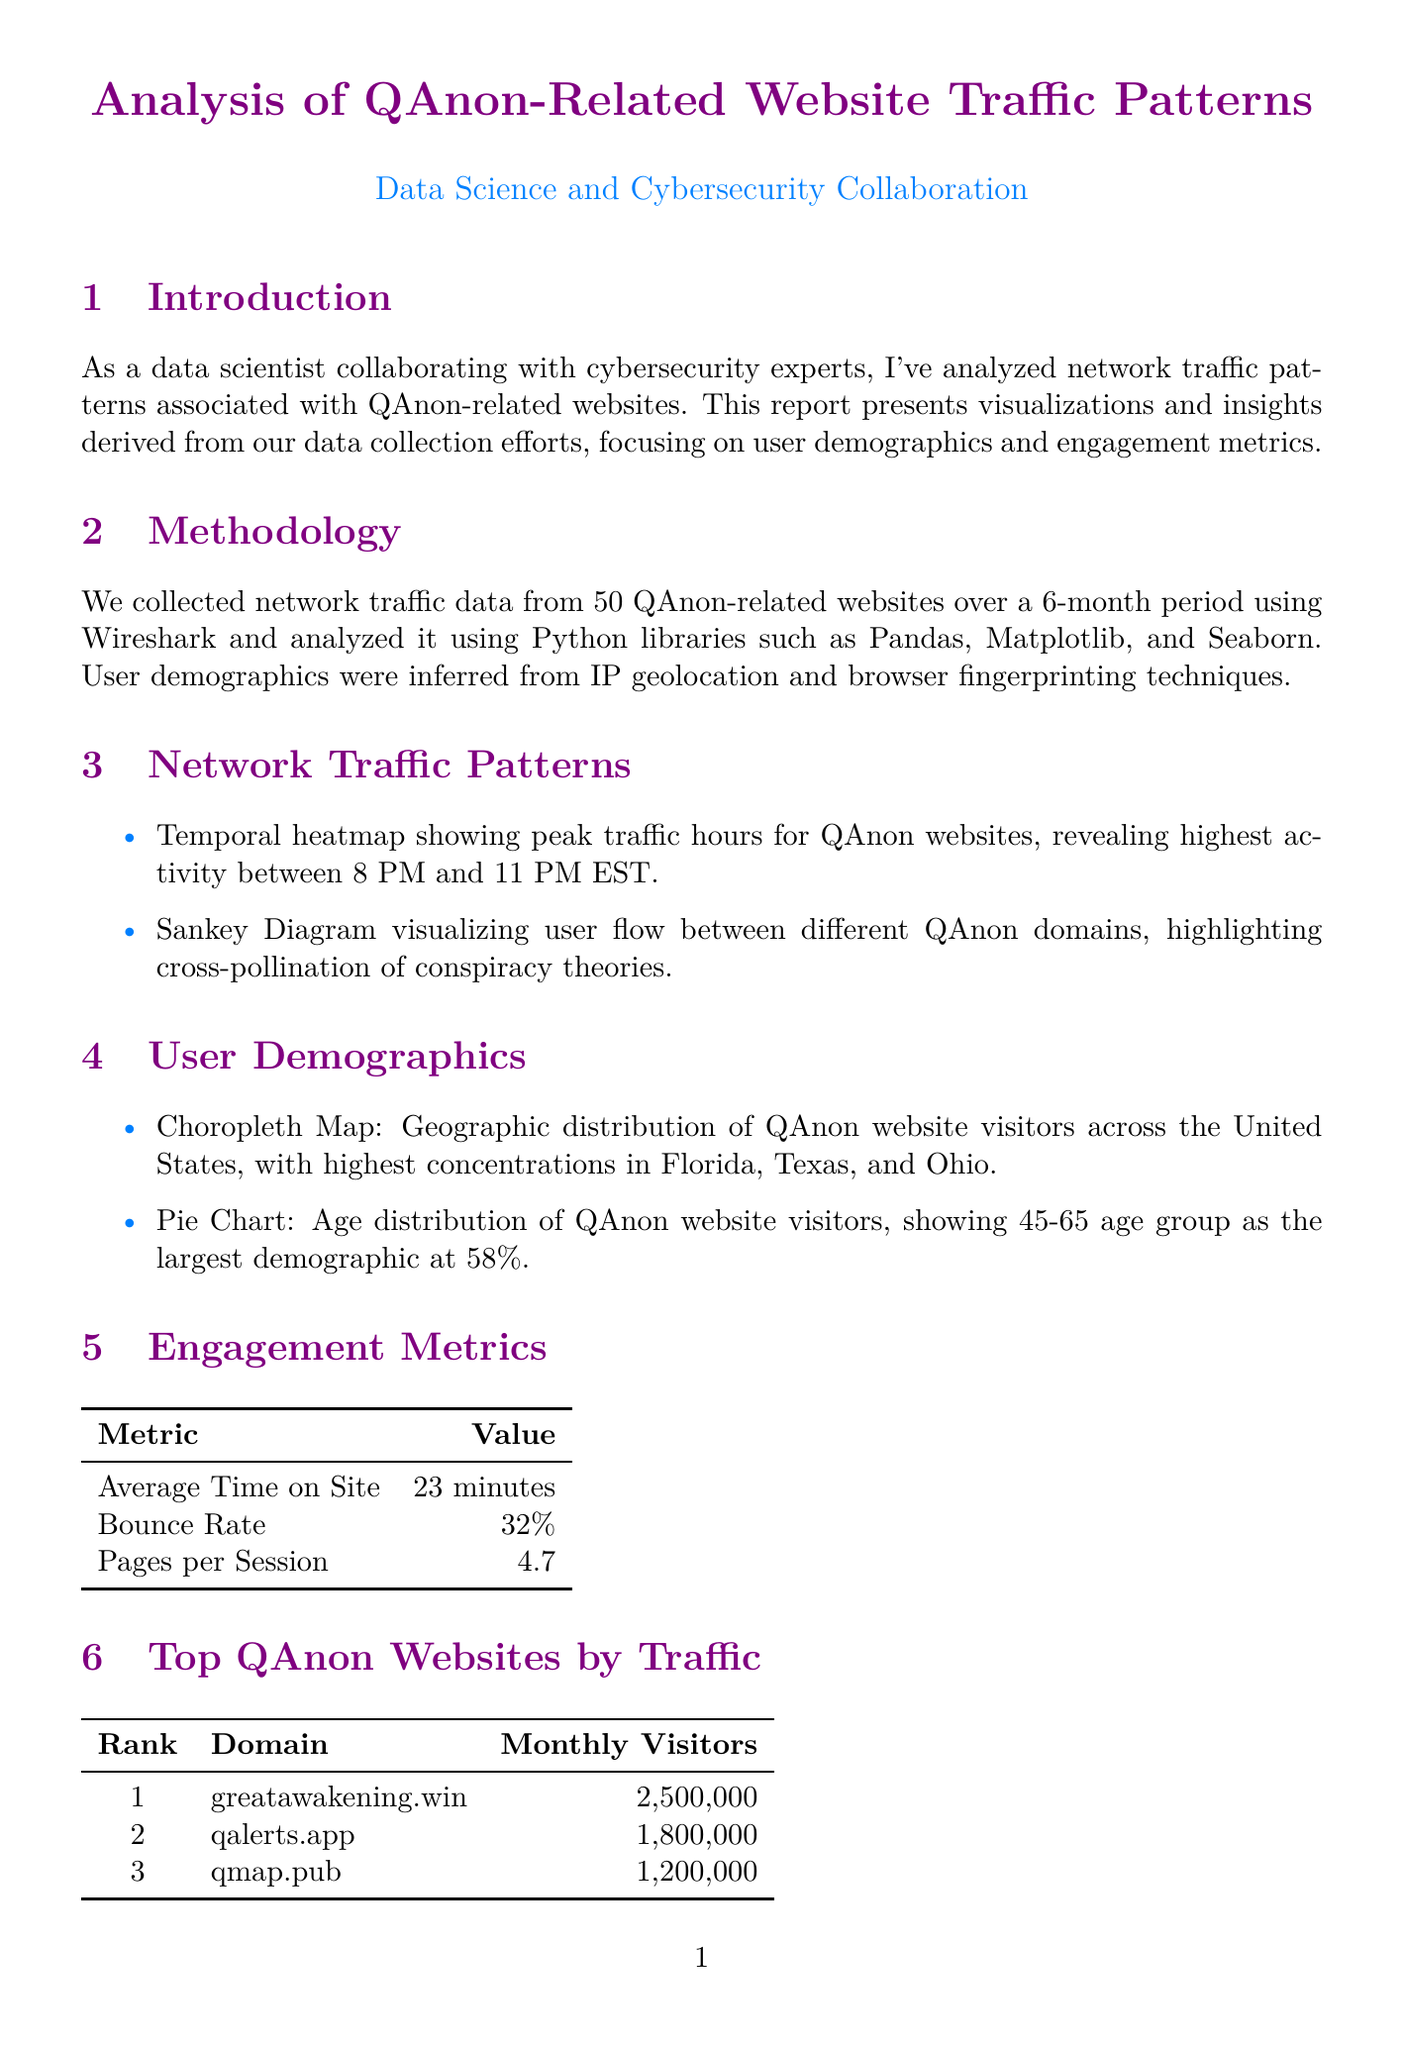what is the title of the report? The title of the report is presented prominently at the beginning of the document.
Answer: Analysis of QAnon-Related Website Traffic Patterns what is the average time on site for visitors? The average time on site is provided as a specific engagement metric within the report.
Answer: 23 minutes which age group comprises the largest demographic of QAnon website visitors? The age distribution information reveals the largest demographic group of visitors.
Answer: 45-65 how many monthly visitors does greatawakening.win have? The monthly visitors for greatawakening.win are specified in the section detailing top QAnon websites by traffic.
Answer: 2,500,000 what tools were used for the analysis? The tools utilized for analysis are listed at the end of the report, highlighting the technologies involved.
Answer: Python, Wireshark, Elasticsearch, Kibana, TensorFlow what is the bounce rate reported for QAnon websites? The bounce rate is listed as a specific engagement metric within the document.
Answer: 32% which state has the highest concentration of QAnon website visitors? Geographic distribution data indicates which state has the highest visitor concentration.
Answer: Florida what is the primary source of user demographic information? The methodology describes how user demographics were inferred, indicating the main source of this information.
Answer: IP geolocation and browser fingerprinting what peak hours of activity are indicated for QAnon websites? The temporal heatmap visualizes when the most traffic occurs and identifies those peak hours.
Answer: 8 PM to 11 PM EST 